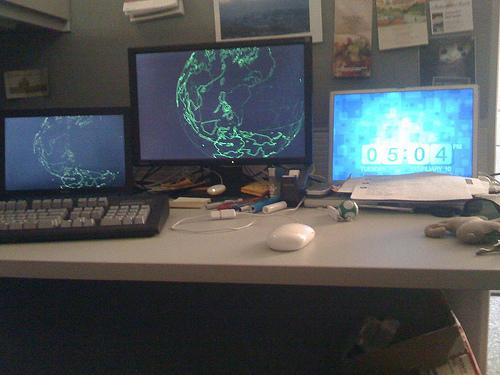Determine the number of picture-related items in the image. There are at least four picture-related items in the image, including a picture hanging on the wall, pictures on a cubicle wall, a bent paper on the wall, and a picture tacked to the wall. Identify the objects visible on the desk and a brief description of their location. Objects on the desk include a white mouse in the center, keyboard to the left, computer monitors on the back, white wire in the middle, blue highlighter near the mouse, and stuffed elephant in the right area of the desk. How many keyboards are there in the image, and what are their main colors? There are three keyboards in the image. One is large and black, another is black and white, and the third one is white. How many computer monitors are on the desk, and what are they displaying? There are three computer monitors on the desk. One displays a green globe, another a digital clock, and the third has a black and green representation of the Earth. Provide an evaluation of the sentiment portrayed in this image. The image portrays a professional and organized workspace, with computers, keyboard, and other office supplies, suggesting a neutral to positive sentiment. Analyze the interaction between office supplies visible in the image. Several office supplies coexist in a practical configuration, such as the keyboard and the computer monitors being in proximity to each other, and the white mouse, blue highlighter, and stuffed elephant being nearby. This suggests an organized and functional office workspace. 